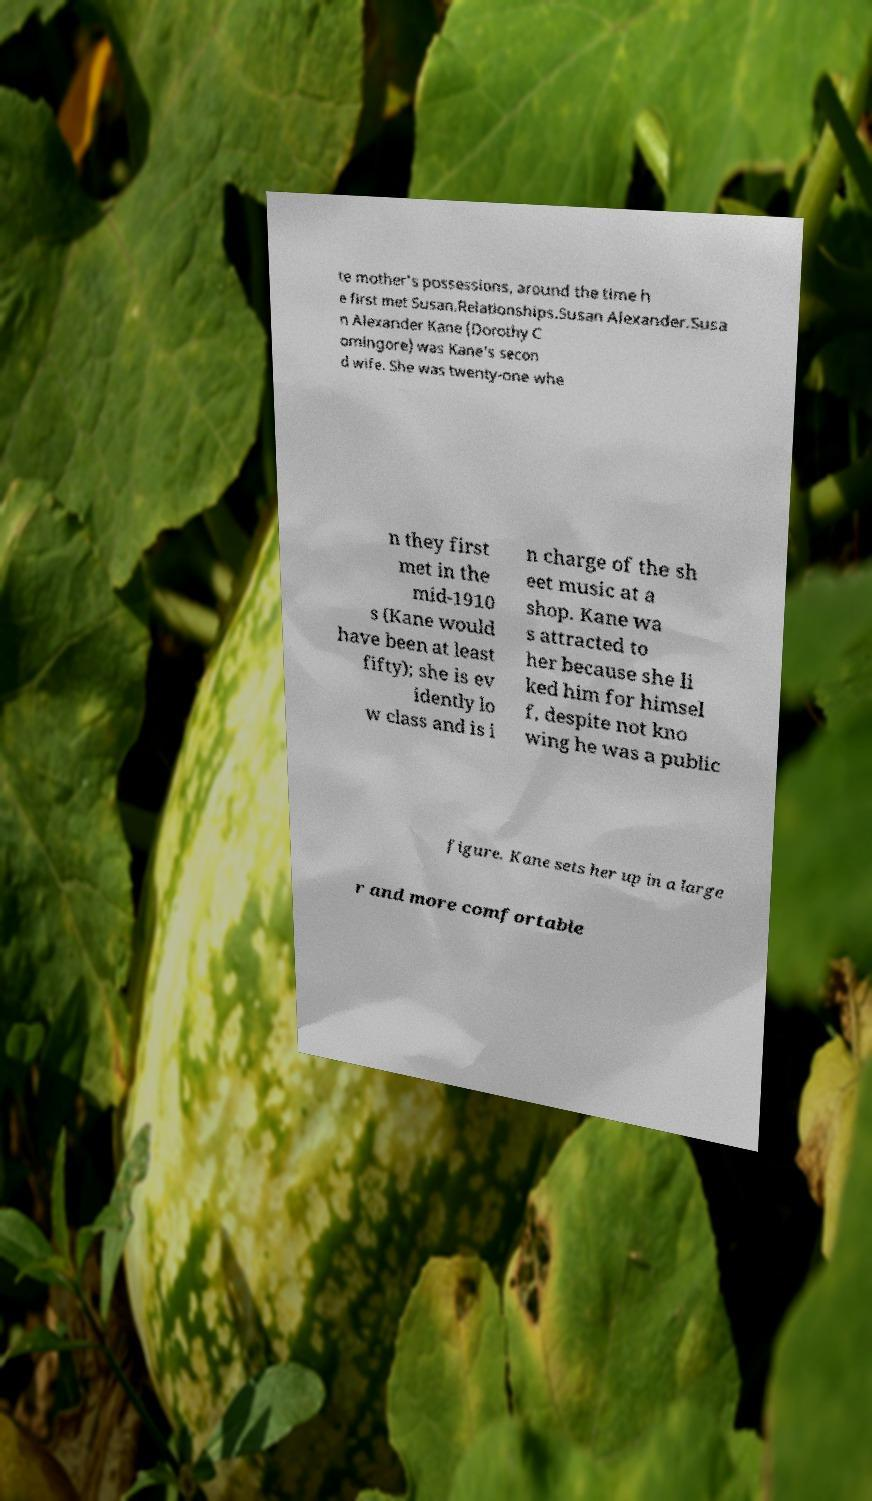Could you extract and type out the text from this image? te mother's possessions, around the time h e first met Susan.Relationships.Susan Alexander.Susa n Alexander Kane (Dorothy C omingore) was Kane's secon d wife. She was twenty-one whe n they first met in the mid-1910 s (Kane would have been at least fifty); she is ev idently lo w class and is i n charge of the sh eet music at a shop. Kane wa s attracted to her because she li ked him for himsel f, despite not kno wing he was a public figure. Kane sets her up in a large r and more comfortable 